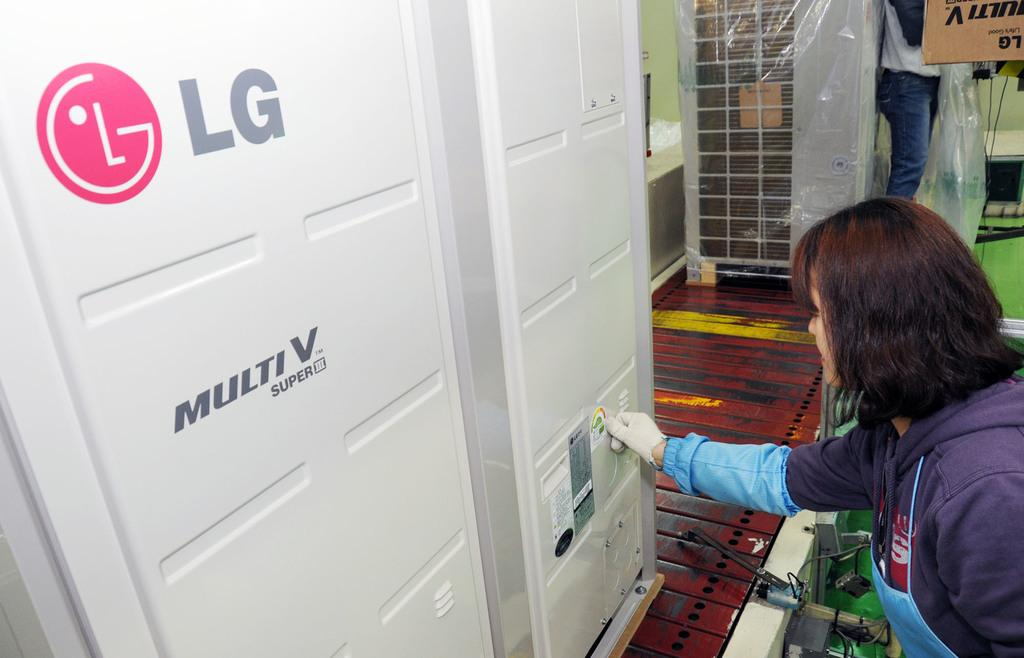<image>
Describe the image concisely. A door with a LG logo on it. 